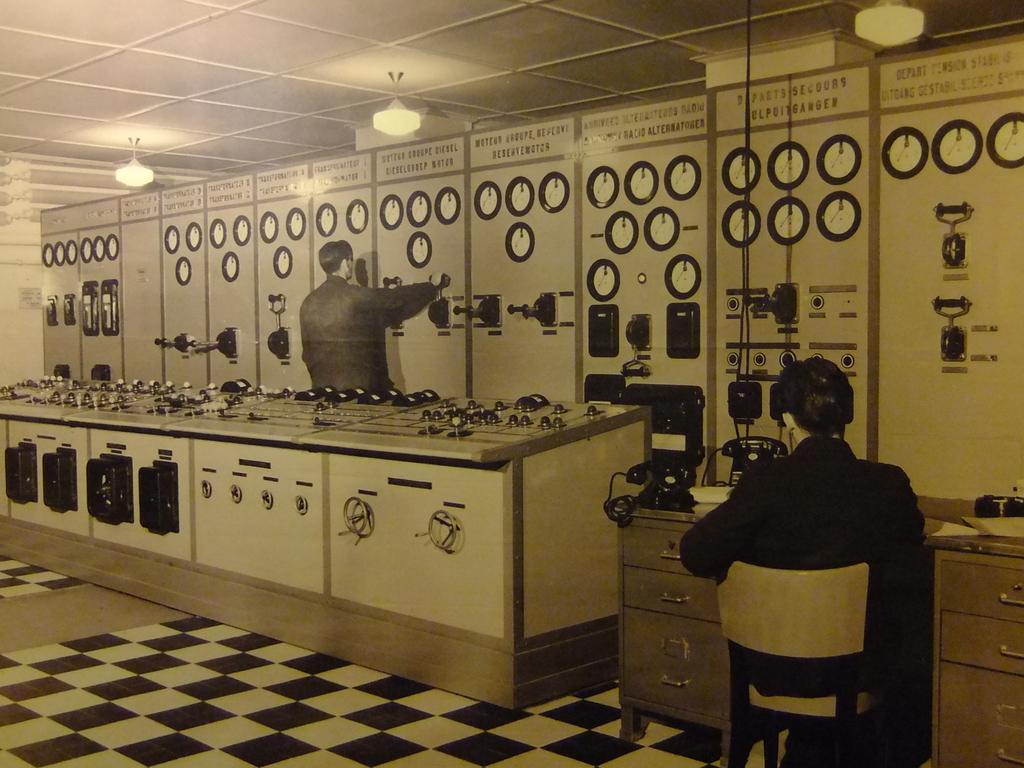Please provide a concise description of this image. The person in left is operating a machine in front of him and the person in the right is sitting in front of a table which has telephones on it. 